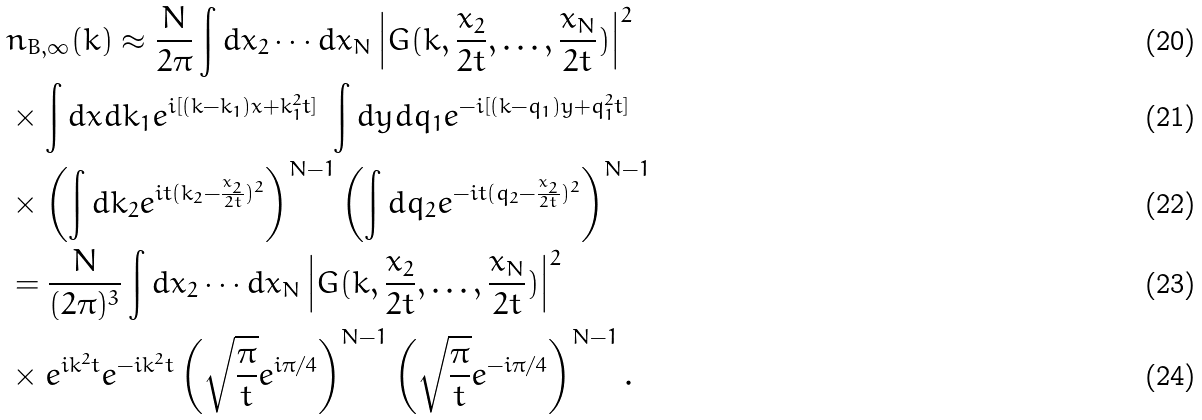<formula> <loc_0><loc_0><loc_500><loc_500>& n _ { B , \infty } ( k ) \approx \frac { N } { 2 \pi } \int d x _ { 2 } \cdots d x _ { N } \left | G ( k , \frac { x _ { 2 } } { 2 t } , \dots , \frac { x _ { N } } { 2 t } ) \right | ^ { 2 } \\ & \times \int d x d k _ { 1 } e ^ { i [ ( k - k _ { 1 } ) x + k _ { 1 } ^ { 2 } t ] } \ \int d y d q _ { 1 } e ^ { - i [ ( k - q _ { 1 } ) y + q _ { 1 } ^ { 2 } t ] } \\ & \times \left ( \int d k _ { 2 } e ^ { i t ( k _ { 2 } - \frac { x _ { 2 } } { 2 t } ) ^ { 2 } } \right ) ^ { N - 1 } \left ( \int d q _ { 2 } e ^ { - i t ( q _ { 2 } - \frac { x _ { 2 } } { 2 t } ) ^ { 2 } } \right ) ^ { N - 1 } \\ & = \frac { N } { ( 2 \pi ) ^ { 3 } } \int d x _ { 2 } \cdots d x _ { N } \left | G ( k , \frac { x _ { 2 } } { 2 t } , \dots , \frac { x _ { N } } { 2 t } ) \right | ^ { 2 } \\ & \times e ^ { i k ^ { 2 } t } e ^ { - i k ^ { 2 } t } \left ( \sqrt { \frac { \pi } { t } } e ^ { i \pi / 4 } \right ) ^ { N - 1 } \left ( \sqrt { \frac { \pi } { t } } e ^ { - i \pi / 4 } \right ) ^ { N - 1 } .</formula> 